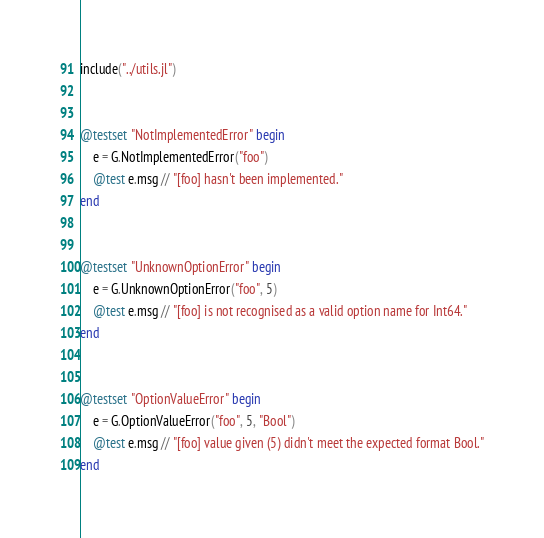Convert code to text. <code><loc_0><loc_0><loc_500><loc_500><_Julia_>include("../utils.jl")


@testset "NotImplementedError" begin
    e = G.NotImplementedError("foo")
    @test e.msg // "[foo] hasn't been implemented."
end


@testset "UnknownOptionError" begin
    e = G.UnknownOptionError("foo", 5)
    @test e.msg // "[foo] is not recognised as a valid option name for Int64."
end


@testset "OptionValueError" begin
    e = G.OptionValueError("foo", 5, "Bool")
    @test e.msg // "[foo] value given (5) didn't meet the expected format Bool."
end
</code> 